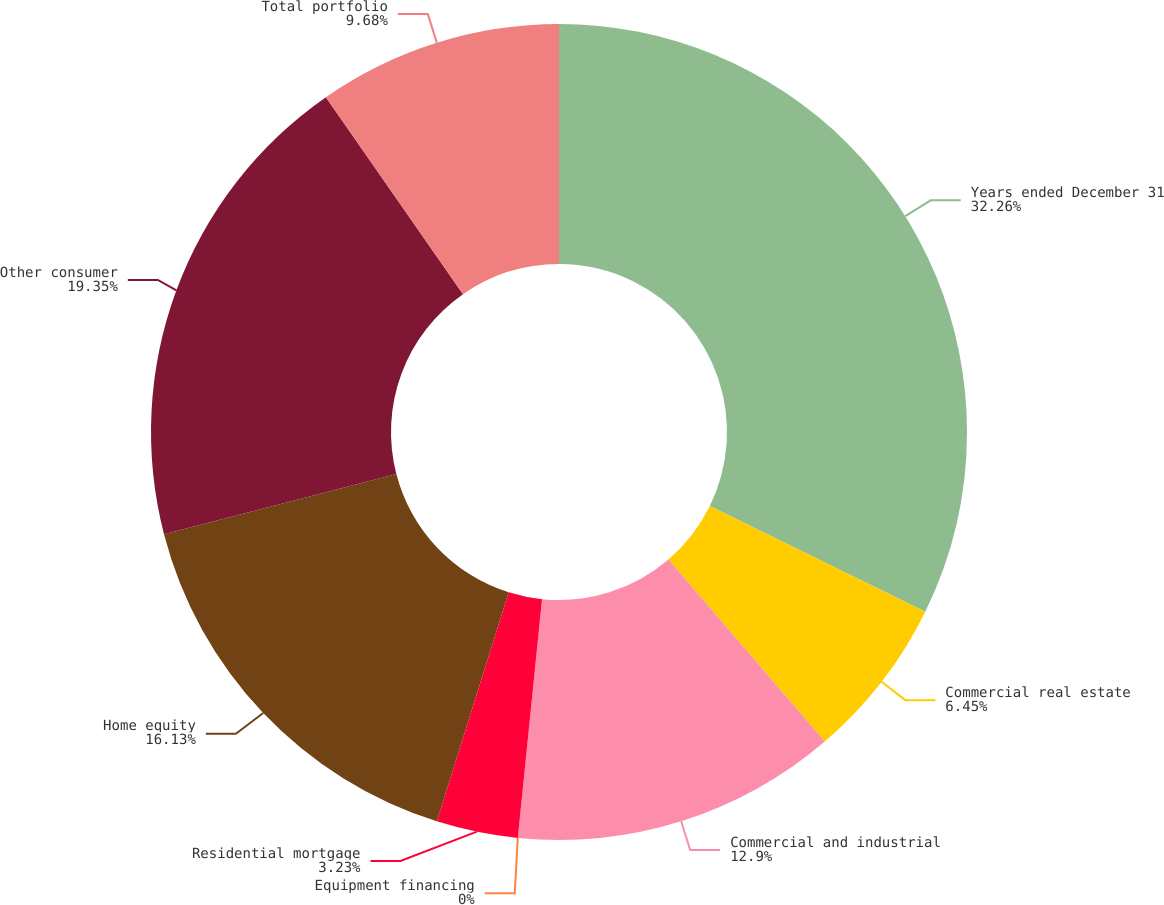<chart> <loc_0><loc_0><loc_500><loc_500><pie_chart><fcel>Years ended December 31<fcel>Commercial real estate<fcel>Commercial and industrial<fcel>Equipment financing<fcel>Residential mortgage<fcel>Home equity<fcel>Other consumer<fcel>Total portfolio<nl><fcel>32.26%<fcel>6.45%<fcel>12.9%<fcel>0.0%<fcel>3.23%<fcel>16.13%<fcel>19.35%<fcel>9.68%<nl></chart> 